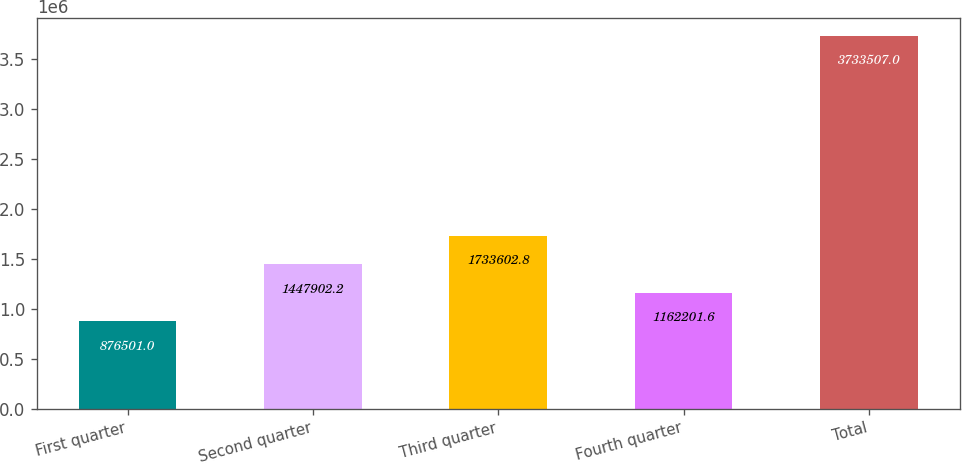Convert chart to OTSL. <chart><loc_0><loc_0><loc_500><loc_500><bar_chart><fcel>First quarter<fcel>Second quarter<fcel>Third quarter<fcel>Fourth quarter<fcel>Total<nl><fcel>876501<fcel>1.4479e+06<fcel>1.7336e+06<fcel>1.1622e+06<fcel>3.73351e+06<nl></chart> 